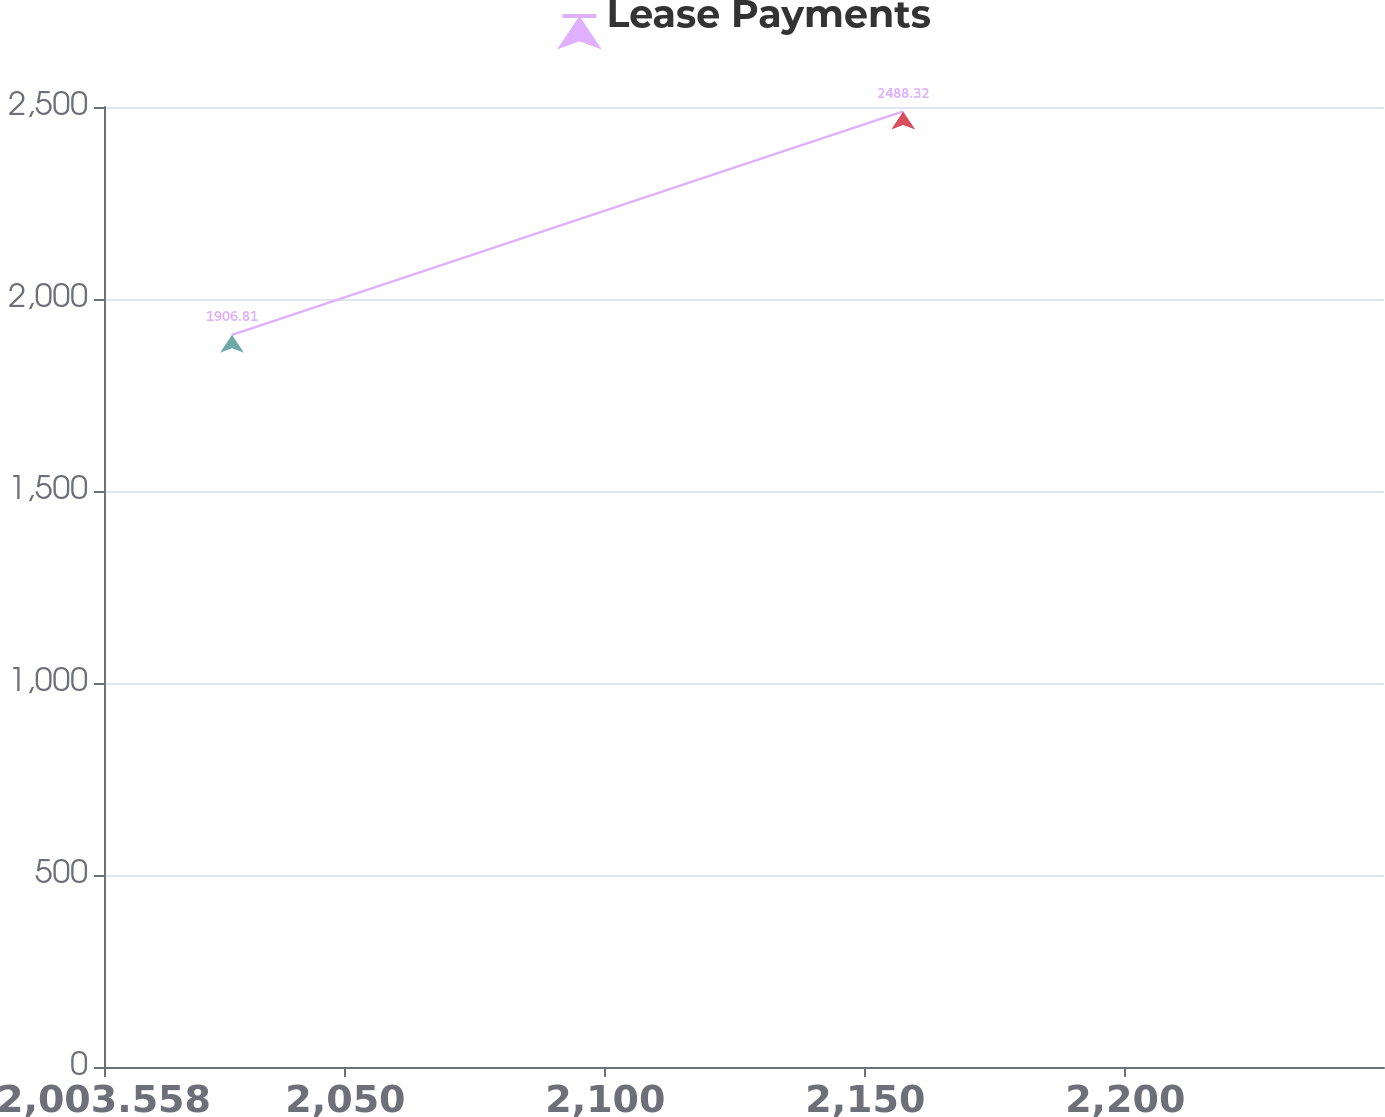Convert chart to OTSL. <chart><loc_0><loc_0><loc_500><loc_500><line_chart><ecel><fcel>Lease Payments<nl><fcel>2028.18<fcel>1906.81<nl><fcel>2157.29<fcel>2488.32<nl><fcel>2274.4<fcel>1842.2<nl></chart> 